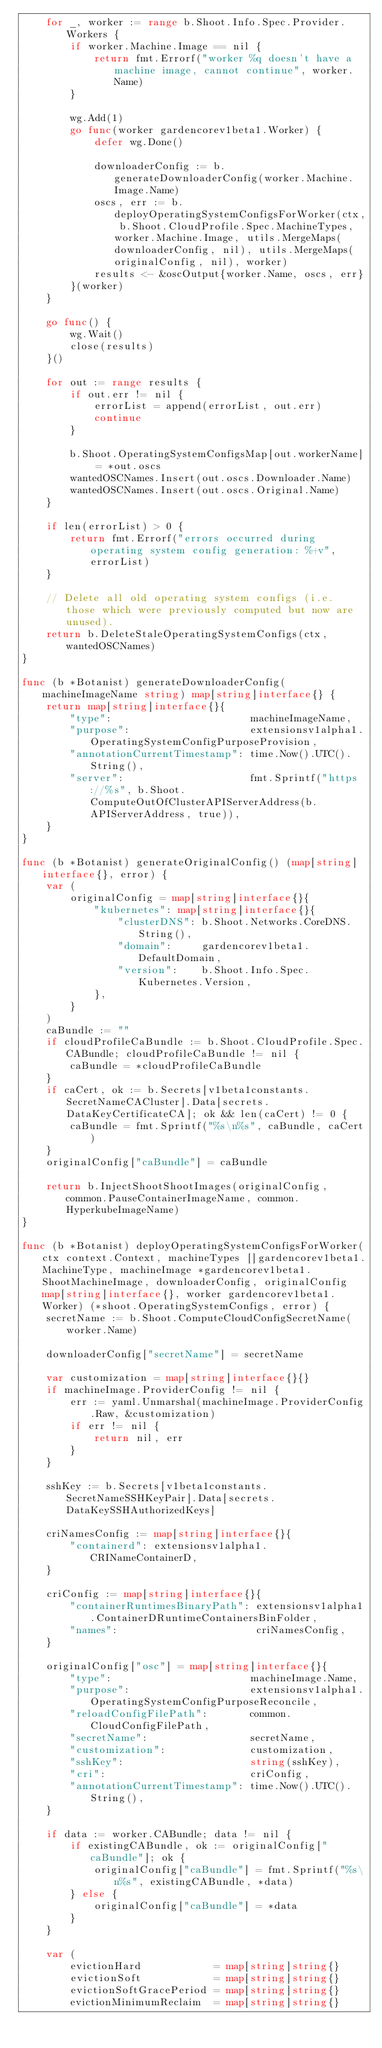Convert code to text. <code><loc_0><loc_0><loc_500><loc_500><_Go_>	for _, worker := range b.Shoot.Info.Spec.Provider.Workers {
		if worker.Machine.Image == nil {
			return fmt.Errorf("worker %q doesn't have a machine image, cannot continue", worker.Name)
		}

		wg.Add(1)
		go func(worker gardencorev1beta1.Worker) {
			defer wg.Done()

			downloaderConfig := b.generateDownloaderConfig(worker.Machine.Image.Name)
			oscs, err := b.deployOperatingSystemConfigsForWorker(ctx, b.Shoot.CloudProfile.Spec.MachineTypes, worker.Machine.Image, utils.MergeMaps(downloaderConfig, nil), utils.MergeMaps(originalConfig, nil), worker)
			results <- &oscOutput{worker.Name, oscs, err}
		}(worker)
	}

	go func() {
		wg.Wait()
		close(results)
	}()

	for out := range results {
		if out.err != nil {
			errorList = append(errorList, out.err)
			continue
		}

		b.Shoot.OperatingSystemConfigsMap[out.workerName] = *out.oscs
		wantedOSCNames.Insert(out.oscs.Downloader.Name)
		wantedOSCNames.Insert(out.oscs.Original.Name)
	}

	if len(errorList) > 0 {
		return fmt.Errorf("errors occurred during operating system config generation: %+v", errorList)
	}

	// Delete all old operating system configs (i.e. those which were previously computed but now are unused).
	return b.DeleteStaleOperatingSystemConfigs(ctx, wantedOSCNames)
}

func (b *Botanist) generateDownloaderConfig(machineImageName string) map[string]interface{} {
	return map[string]interface{}{
		"type":                       machineImageName,
		"purpose":                    extensionsv1alpha1.OperatingSystemConfigPurposeProvision,
		"annotationCurrentTimestamp": time.Now().UTC().String(),
		"server":                     fmt.Sprintf("https://%s", b.Shoot.ComputeOutOfClusterAPIServerAddress(b.APIServerAddress, true)),
	}
}

func (b *Botanist) generateOriginalConfig() (map[string]interface{}, error) {
	var (
		originalConfig = map[string]interface{}{
			"kubernetes": map[string]interface{}{
				"clusterDNS": b.Shoot.Networks.CoreDNS.String(),
				"domain":     gardencorev1beta1.DefaultDomain,
				"version":    b.Shoot.Info.Spec.Kubernetes.Version,
			},
		}
	)
	caBundle := ""
	if cloudProfileCaBundle := b.Shoot.CloudProfile.Spec.CABundle; cloudProfileCaBundle != nil {
		caBundle = *cloudProfileCaBundle
	}
	if caCert, ok := b.Secrets[v1beta1constants.SecretNameCACluster].Data[secrets.DataKeyCertificateCA]; ok && len(caCert) != 0 {
		caBundle = fmt.Sprintf("%s\n%s", caBundle, caCert)
	}
	originalConfig["caBundle"] = caBundle

	return b.InjectShootShootImages(originalConfig, common.PauseContainerImageName, common.HyperkubeImageName)
}

func (b *Botanist) deployOperatingSystemConfigsForWorker(ctx context.Context, machineTypes []gardencorev1beta1.MachineType, machineImage *gardencorev1beta1.ShootMachineImage, downloaderConfig, originalConfig map[string]interface{}, worker gardencorev1beta1.Worker) (*shoot.OperatingSystemConfigs, error) {
	secretName := b.Shoot.ComputeCloudConfigSecretName(worker.Name)

	downloaderConfig["secretName"] = secretName

	var customization = map[string]interface{}{}
	if machineImage.ProviderConfig != nil {
		err := yaml.Unmarshal(machineImage.ProviderConfig.Raw, &customization)
		if err != nil {
			return nil, err
		}
	}

	sshKey := b.Secrets[v1beta1constants.SecretNameSSHKeyPair].Data[secrets.DataKeySSHAuthorizedKeys]

	criNamesConfig := map[string]interface{}{
		"containerd": extensionsv1alpha1.CRINameContainerD,
	}

	criConfig := map[string]interface{}{
		"containerRuntimesBinaryPath": extensionsv1alpha1.ContainerDRuntimeContainersBinFolder,
		"names":                       criNamesConfig,
	}

	originalConfig["osc"] = map[string]interface{}{
		"type":                       machineImage.Name,
		"purpose":                    extensionsv1alpha1.OperatingSystemConfigPurposeReconcile,
		"reloadConfigFilePath":       common.CloudConfigFilePath,
		"secretName":                 secretName,
		"customization":              customization,
		"sshKey":                     string(sshKey),
		"cri":                        criConfig,
		"annotationCurrentTimestamp": time.Now().UTC().String(),
	}

	if data := worker.CABundle; data != nil {
		if existingCABundle, ok := originalConfig["caBundle"]; ok {
			originalConfig["caBundle"] = fmt.Sprintf("%s\n%s", existingCABundle, *data)
		} else {
			originalConfig["caBundle"] = *data
		}
	}

	var (
		evictionHard            = map[string]string{}
		evictionSoft            = map[string]string{}
		evictionSoftGracePeriod = map[string]string{}
		evictionMinimumReclaim  = map[string]string{}</code> 